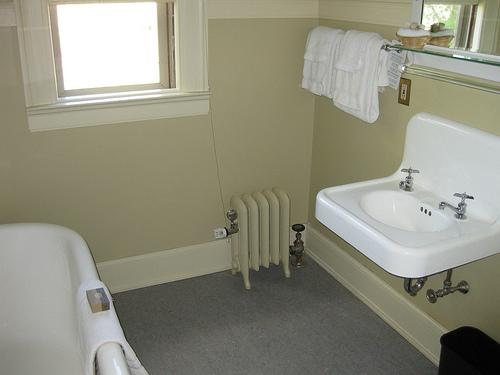Question: what room is this?
Choices:
A. Shower room.
B. Washroom.
C. Bathroom.
D. Restroom.
Answer with the letter. Answer: C Question: who is using the bathroom?
Choices:
A. Grandma.
B. Little Bobby.
C. No one.
D. I am.
Answer with the letter. Answer: C Question: where is the soap?
Choices:
A. In the soap dish.
B. In the pump on the wall.
C. On the edge of the tub.
D. In the pump on the counter.
Answer with the letter. Answer: C Question: what us in the right corner below the window?
Choices:
A. Magazine rack.
B. Small bookcase.
C. Video collection.
D. Radiator.
Answer with the letter. Answer: D Question: where is the sink?
Choices:
A. Between the stove in the refrigerator.
B. In the kitchen.
C. On the far right.
D. Behind the breakfast bar.
Answer with the letter. Answer: C 